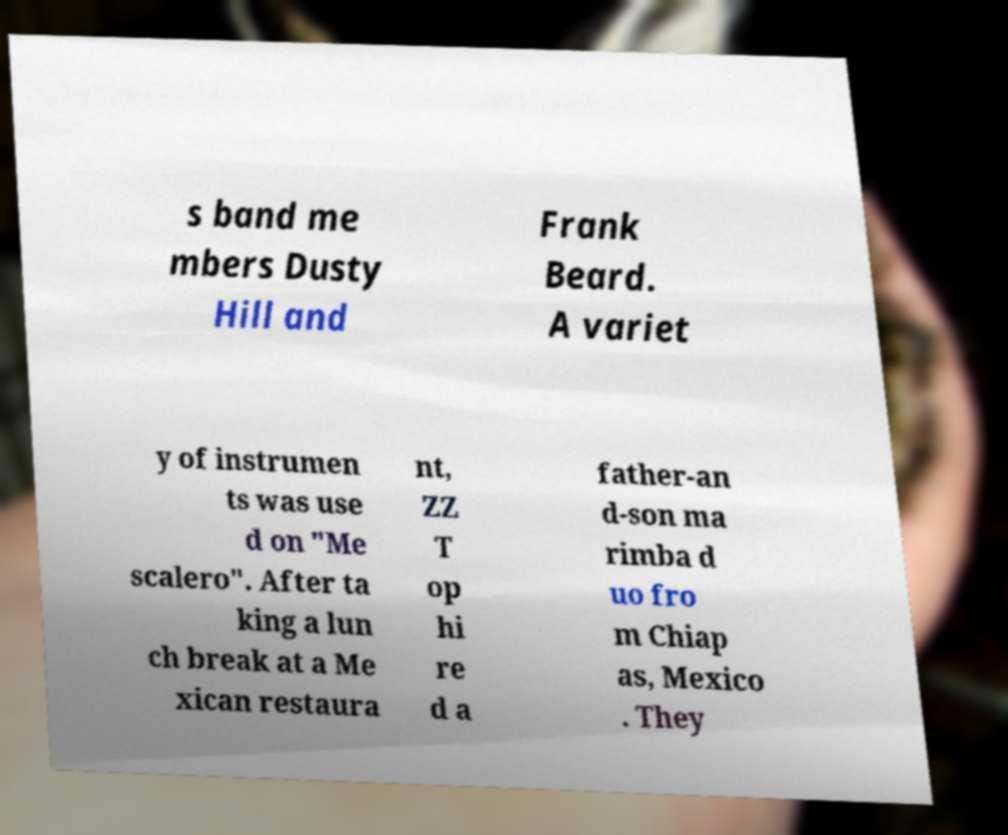What messages or text are displayed in this image? I need them in a readable, typed format. s band me mbers Dusty Hill and Frank Beard. A variet y of instrumen ts was use d on "Me scalero". After ta king a lun ch break at a Me xican restaura nt, ZZ T op hi re d a father-an d-son ma rimba d uo fro m Chiap as, Mexico . They 